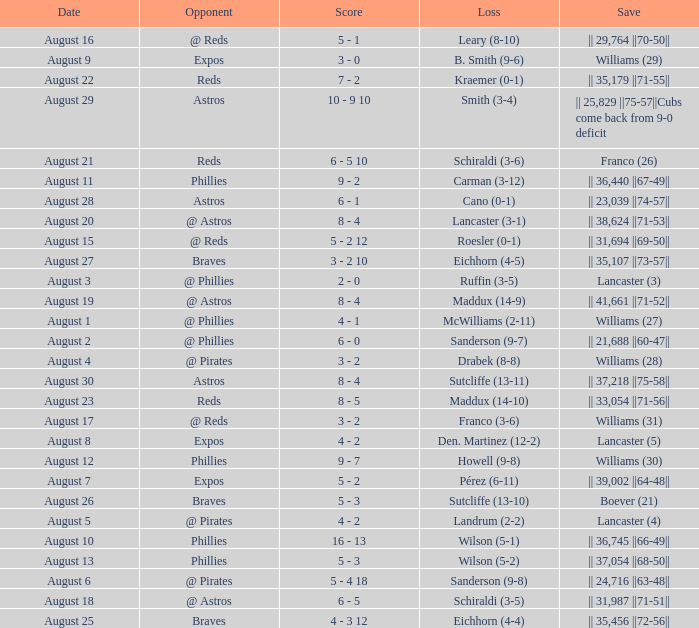Name the date with loss of carman (3-12) August 11. 